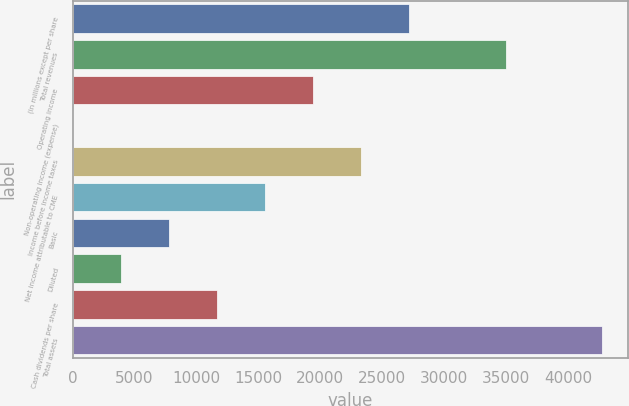<chart> <loc_0><loc_0><loc_500><loc_500><bar_chart><fcel>(in millions except per share<fcel>Total revenues<fcel>Operating income<fcel>Non-operating income (expense)<fcel>Income before income taxes<fcel>Net income attributable to CME<fcel>Basic<fcel>Diluted<fcel>Cash dividends per share<fcel>Total assets<nl><fcel>27204.7<fcel>34977<fcel>19432.3<fcel>1.4<fcel>23318.5<fcel>15546.1<fcel>7773.76<fcel>3887.58<fcel>11659.9<fcel>42749.4<nl></chart> 